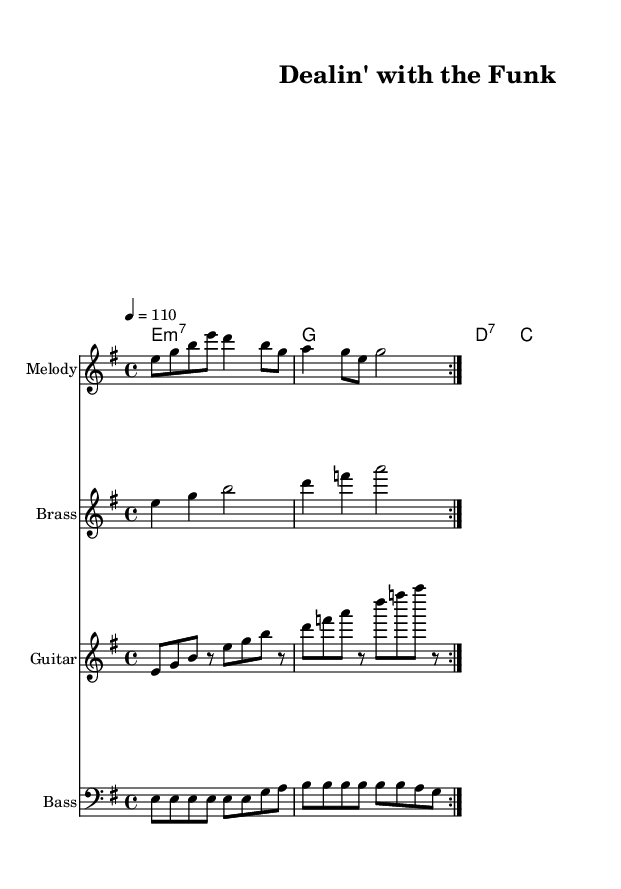What is the key signature of this music? The key signature is indicated by the symbol at the beginning of the staff, showing one sharp (F#), which indicates E minor key.
Answer: E minor What is the time signature of the piece? The time signature is found in the beginning section marked above the staff, showing 4/4, which means there are four beats per measure.
Answer: 4/4 What is the tempo marking for this piece? The tempo marking is located just above the staff, indicating that the speed of the piece is set at 110 beats per minute.
Answer: 110 How many measures are in the electric bass part? The electric bass part repeats a section twice, and each repeat contains one measure, thus counting as a total of 8 measures (4 measures repeated twice).
Answer: 8 What is the main chord progression used in the harmony? The chord progression is determined by examining the chord names written above the staff, which reveals the sequence e minor 7, g major, d dominant 7, and c major.
Answer: e minor 7, g, d dominant 7, c What is the rhythmic pattern used in the melody? The melody shows a rhythmic pattern of eighth and quarter notes predominantly, reflecting typical funk rhythms that create a swinging feel; measures consist of both eighth notes and quarter notes.
Answer: Eighth and quarter notes What type of instruments are featured in this piece? The instruments are indicated by the staff names; they include electric bass, electric guitar, brass section, and melody instruments, typical of funk ensembles.
Answer: Electric bass, electric guitar, brass section, melody 